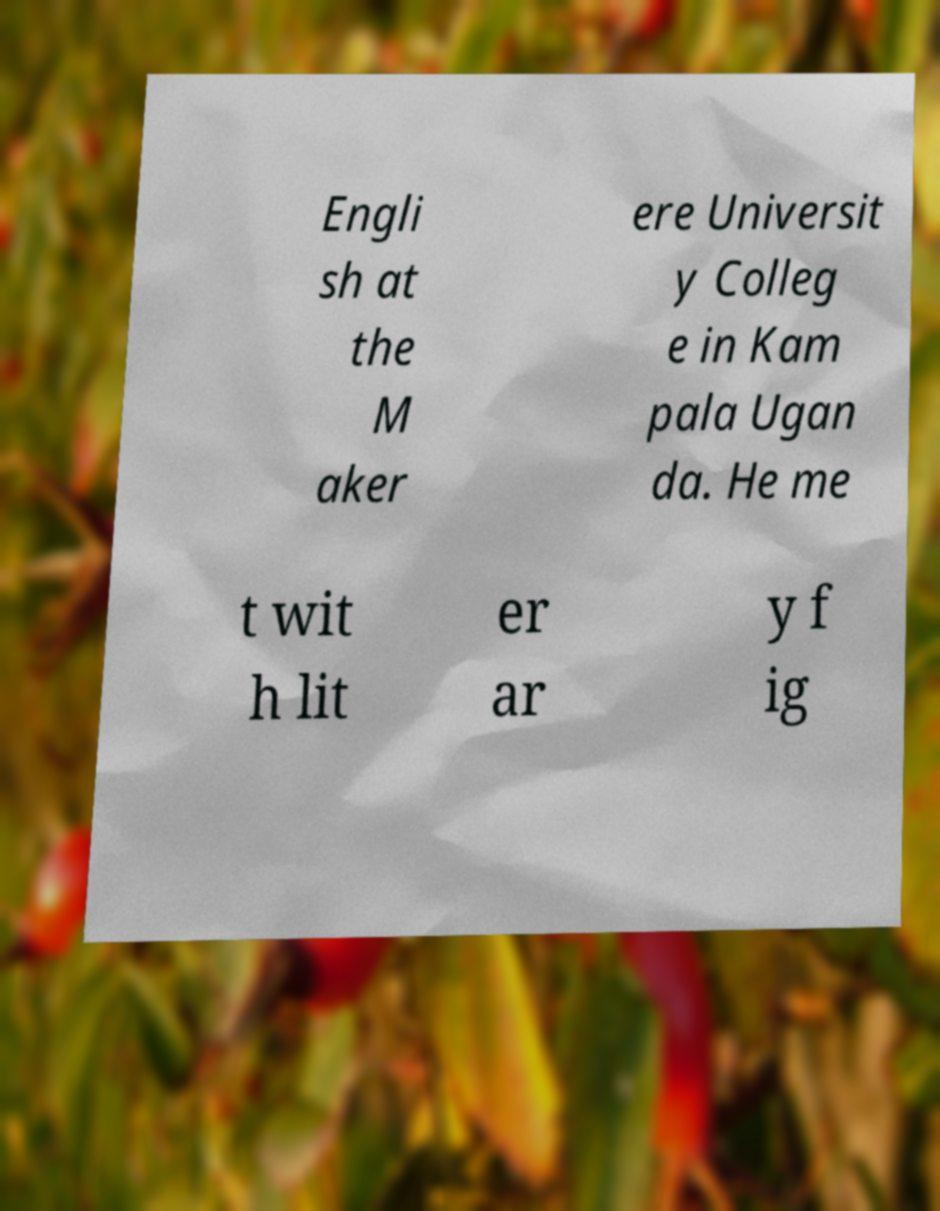Could you assist in decoding the text presented in this image and type it out clearly? Engli sh at the M aker ere Universit y Colleg e in Kam pala Ugan da. He me t wit h lit er ar y f ig 